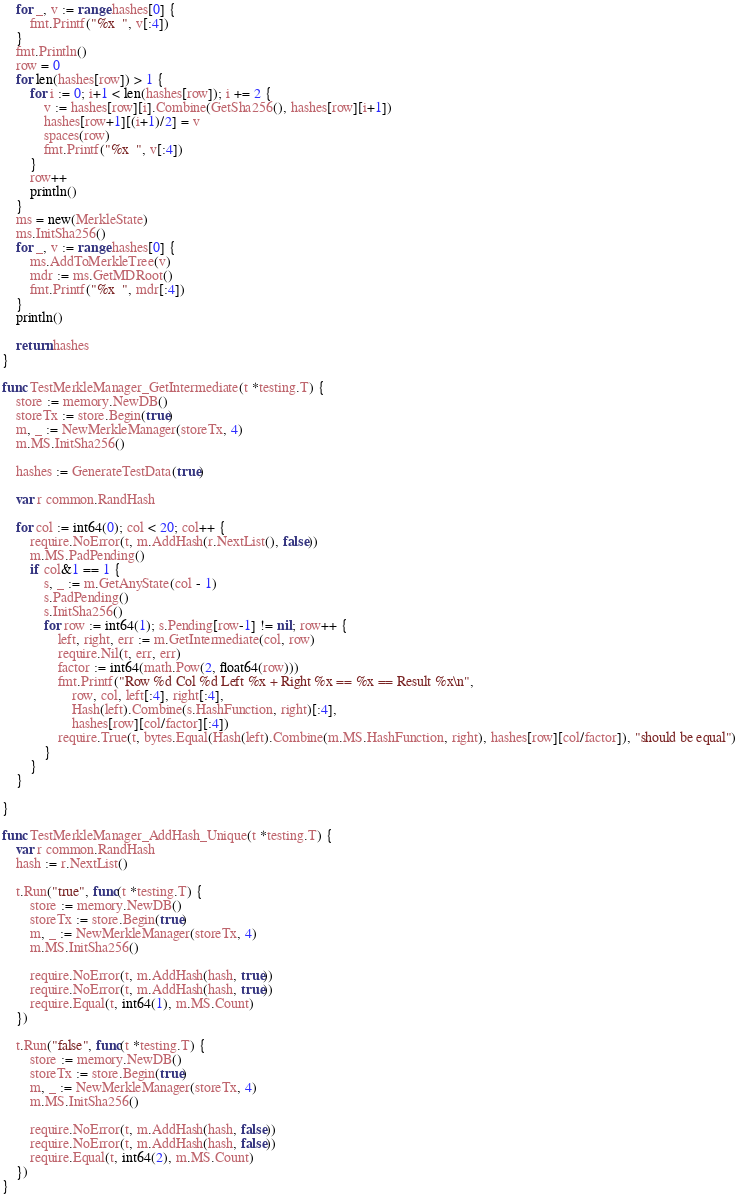Convert code to text. <code><loc_0><loc_0><loc_500><loc_500><_Go_>	for _, v := range hashes[0] {
		fmt.Printf("%x  ", v[:4])
	}
	fmt.Println()
	row = 0
	for len(hashes[row]) > 1 {
		for i := 0; i+1 < len(hashes[row]); i += 2 {
			v := hashes[row][i].Combine(GetSha256(), hashes[row][i+1])
			hashes[row+1][(i+1)/2] = v
			spaces(row)
			fmt.Printf("%x  ", v[:4])
		}
		row++
		println()
	}
	ms = new(MerkleState)
	ms.InitSha256()
	for _, v := range hashes[0] {
		ms.AddToMerkleTree(v)
		mdr := ms.GetMDRoot()
		fmt.Printf("%x  ", mdr[:4])
	}
	println()

	return hashes
}

func TestMerkleManager_GetIntermediate(t *testing.T) {
	store := memory.NewDB()
	storeTx := store.Begin(true)
	m, _ := NewMerkleManager(storeTx, 4)
	m.MS.InitSha256()

	hashes := GenerateTestData(true)

	var r common.RandHash

	for col := int64(0); col < 20; col++ {
		require.NoError(t, m.AddHash(r.NextList(), false))
		m.MS.PadPending()
		if col&1 == 1 {
			s, _ := m.GetAnyState(col - 1)
			s.PadPending()
			s.InitSha256()
			for row := int64(1); s.Pending[row-1] != nil; row++ {
				left, right, err := m.GetIntermediate(col, row)
				require.Nil(t, err, err)
				factor := int64(math.Pow(2, float64(row)))
				fmt.Printf("Row %d Col %d Left %x + Right %x == %x == Result %x\n",
					row, col, left[:4], right[:4],
					Hash(left).Combine(s.HashFunction, right)[:4],
					hashes[row][col/factor][:4])
				require.True(t, bytes.Equal(Hash(left).Combine(m.MS.HashFunction, right), hashes[row][col/factor]), "should be equal")
			}
		}
	}

}

func TestMerkleManager_AddHash_Unique(t *testing.T) {
	var r common.RandHash
	hash := r.NextList()

	t.Run("true", func(t *testing.T) {
		store := memory.NewDB()
		storeTx := store.Begin(true)
		m, _ := NewMerkleManager(storeTx, 4)
		m.MS.InitSha256()

		require.NoError(t, m.AddHash(hash, true))
		require.NoError(t, m.AddHash(hash, true))
		require.Equal(t, int64(1), m.MS.Count)
	})

	t.Run("false", func(t *testing.T) {
		store := memory.NewDB()
		storeTx := store.Begin(true)
		m, _ := NewMerkleManager(storeTx, 4)
		m.MS.InitSha256()

		require.NoError(t, m.AddHash(hash, false))
		require.NoError(t, m.AddHash(hash, false))
		require.Equal(t, int64(2), m.MS.Count)
	})
}
</code> 